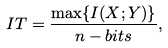Convert formula to latex. <formula><loc_0><loc_0><loc_500><loc_500>I T = \frac { \max \{ I ( X ; Y ) \} } { n - b i t s } ,</formula> 